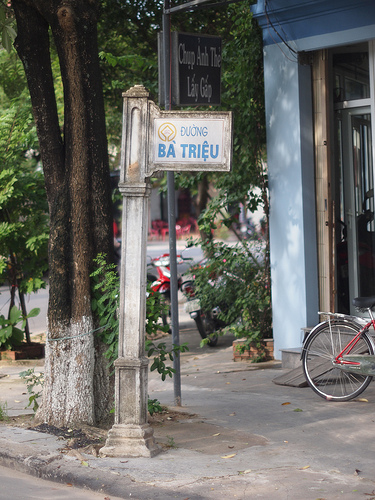What might be the significance of this place to the local community? This street with its distinctive signpost likely serves as a familiar landmark and a place of gathering for the local community. It might be a spot where people meet to catch up, where market vendors sell their goods, and where everyday stories of life unfold. The trees and surroundings provide a small but cherished green space amidst the urban setting, adding to the area's charm and significance. What kind of store might be found near this location? Near this location, one might find a variety of stores: a small grocery selling fresh produce, a quaint coffee shop where locals gather, a bicycle repair shop given the bike in the image, and perhaps a tailor shop, reflecting the artisanal spirit of the neighborhood. 